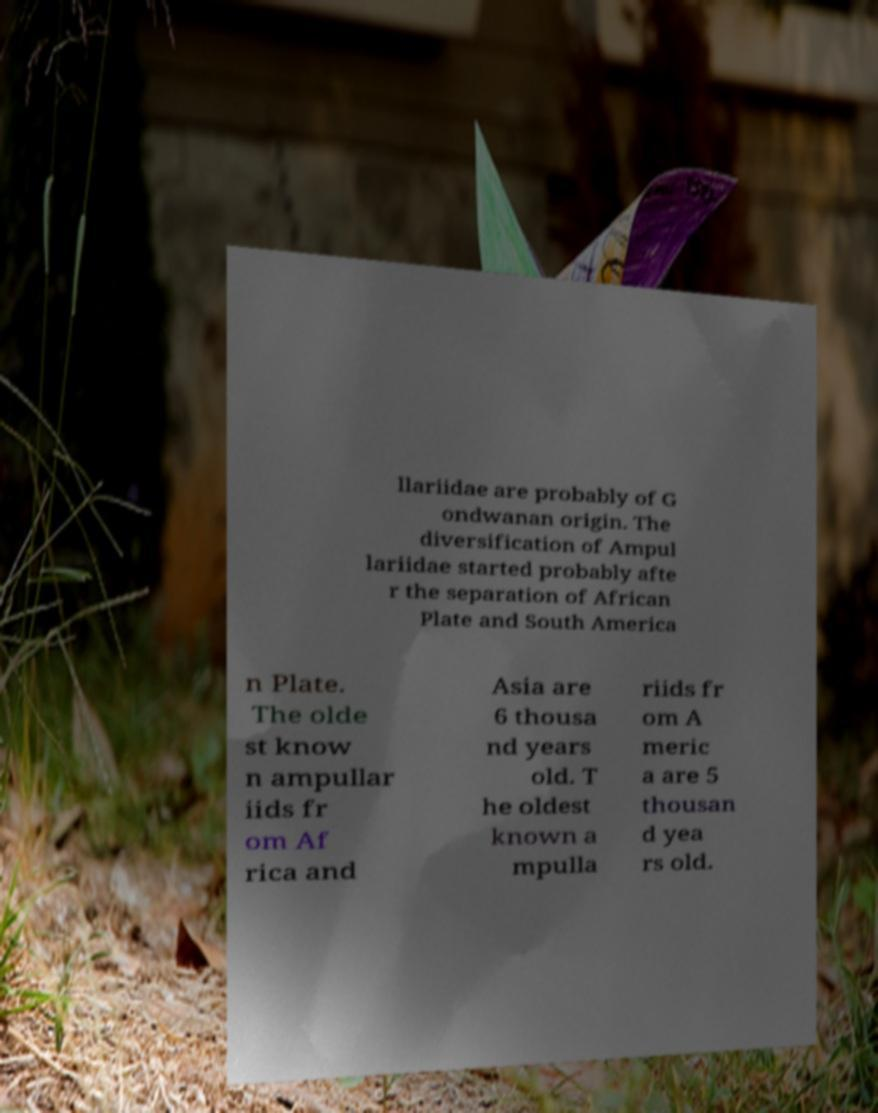Please identify and transcribe the text found in this image. llariidae are probably of G ondwanan origin. The diversification of Ampul lariidae started probably afte r the separation of African Plate and South America n Plate. The olde st know n ampullar iids fr om Af rica and Asia are 6 thousa nd years old. T he oldest known a mpulla riids fr om A meric a are 5 thousan d yea rs old. 